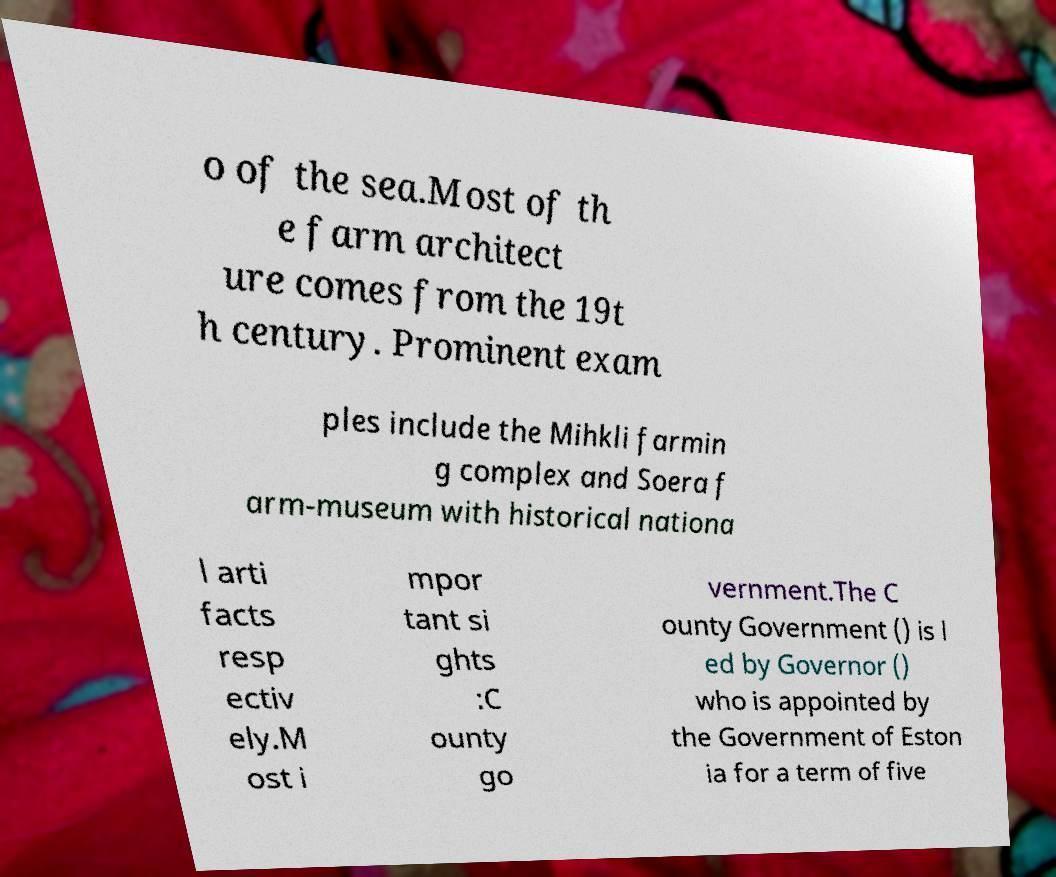Can you read and provide the text displayed in the image?This photo seems to have some interesting text. Can you extract and type it out for me? o of the sea.Most of th e farm architect ure comes from the 19t h century. Prominent exam ples include the Mihkli farmin g complex and Soera f arm-museum with historical nationa l arti facts resp ectiv ely.M ost i mpor tant si ghts :C ounty go vernment.The C ounty Government () is l ed by Governor () who is appointed by the Government of Eston ia for a term of five 